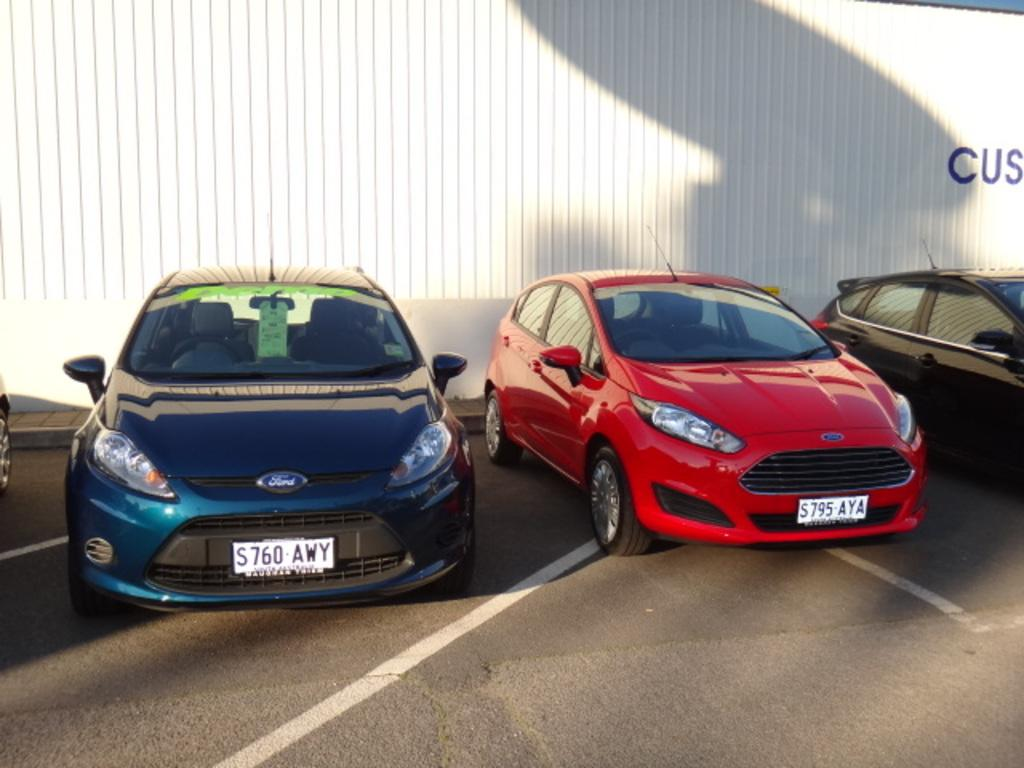What is the main subject of the image? The main subject of the image is cars. What is located in the foreground of the image? There is a road in the foreground of the image. What can be seen in the background of the image? There is a white color object in the background of the image, which might be a wall. How many diseases can be seen in the image? There are no diseases present in the image; it features cars, a road, and a white color object in the background. 